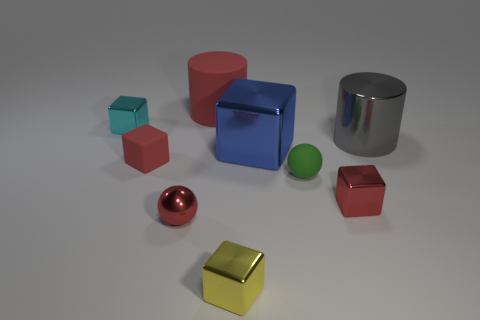Does the cylinder that is in front of the cyan cube have the same color as the big metallic block?
Your response must be concise. No. There is a cyan object that is the same size as the yellow metal cube; what shape is it?
Your answer should be compact. Cube. How many other things are the same color as the big rubber cylinder?
Provide a succinct answer. 3. How many other things are the same material as the cyan object?
Your answer should be very brief. 5. There is a rubber block; is it the same size as the cylinder that is behind the large gray shiny cylinder?
Make the answer very short. No. What color is the large metal cube?
Give a very brief answer. Blue. There is a red matte object in front of the cylinder that is right of the small block that is in front of the small red sphere; what shape is it?
Your response must be concise. Cube. There is a small cube behind the red matte thing in front of the large matte cylinder; what is it made of?
Make the answer very short. Metal. There is a tiny cyan object that is the same material as the big blue block; what shape is it?
Your answer should be very brief. Cube. Is there anything else that has the same shape as the tiny green object?
Your answer should be compact. Yes. 